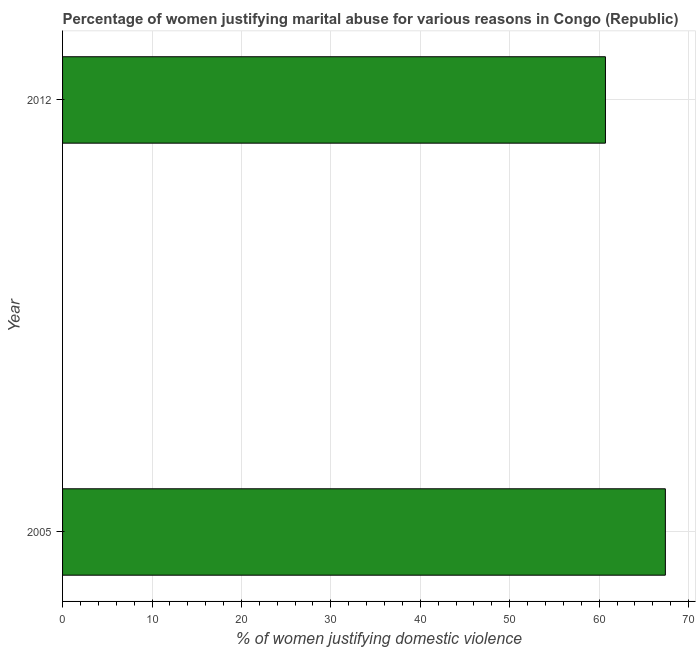Does the graph contain any zero values?
Keep it short and to the point. No. Does the graph contain grids?
Offer a very short reply. Yes. What is the title of the graph?
Make the answer very short. Percentage of women justifying marital abuse for various reasons in Congo (Republic). What is the label or title of the X-axis?
Ensure brevity in your answer.  % of women justifying domestic violence. What is the label or title of the Y-axis?
Provide a short and direct response. Year. What is the percentage of women justifying marital abuse in 2005?
Provide a succinct answer. 67.4. Across all years, what is the maximum percentage of women justifying marital abuse?
Your answer should be compact. 67.4. Across all years, what is the minimum percentage of women justifying marital abuse?
Provide a succinct answer. 60.7. In which year was the percentage of women justifying marital abuse maximum?
Give a very brief answer. 2005. In which year was the percentage of women justifying marital abuse minimum?
Make the answer very short. 2012. What is the sum of the percentage of women justifying marital abuse?
Make the answer very short. 128.1. What is the difference between the percentage of women justifying marital abuse in 2005 and 2012?
Offer a terse response. 6.7. What is the average percentage of women justifying marital abuse per year?
Ensure brevity in your answer.  64.05. What is the median percentage of women justifying marital abuse?
Offer a very short reply. 64.05. Do a majority of the years between 2012 and 2005 (inclusive) have percentage of women justifying marital abuse greater than 32 %?
Your response must be concise. No. What is the ratio of the percentage of women justifying marital abuse in 2005 to that in 2012?
Offer a very short reply. 1.11. Is the percentage of women justifying marital abuse in 2005 less than that in 2012?
Your response must be concise. No. In how many years, is the percentage of women justifying marital abuse greater than the average percentage of women justifying marital abuse taken over all years?
Your response must be concise. 1. How many bars are there?
Keep it short and to the point. 2. Are all the bars in the graph horizontal?
Provide a short and direct response. Yes. How many years are there in the graph?
Provide a short and direct response. 2. What is the difference between two consecutive major ticks on the X-axis?
Give a very brief answer. 10. What is the % of women justifying domestic violence in 2005?
Keep it short and to the point. 67.4. What is the % of women justifying domestic violence in 2012?
Your answer should be very brief. 60.7. What is the ratio of the % of women justifying domestic violence in 2005 to that in 2012?
Offer a terse response. 1.11. 